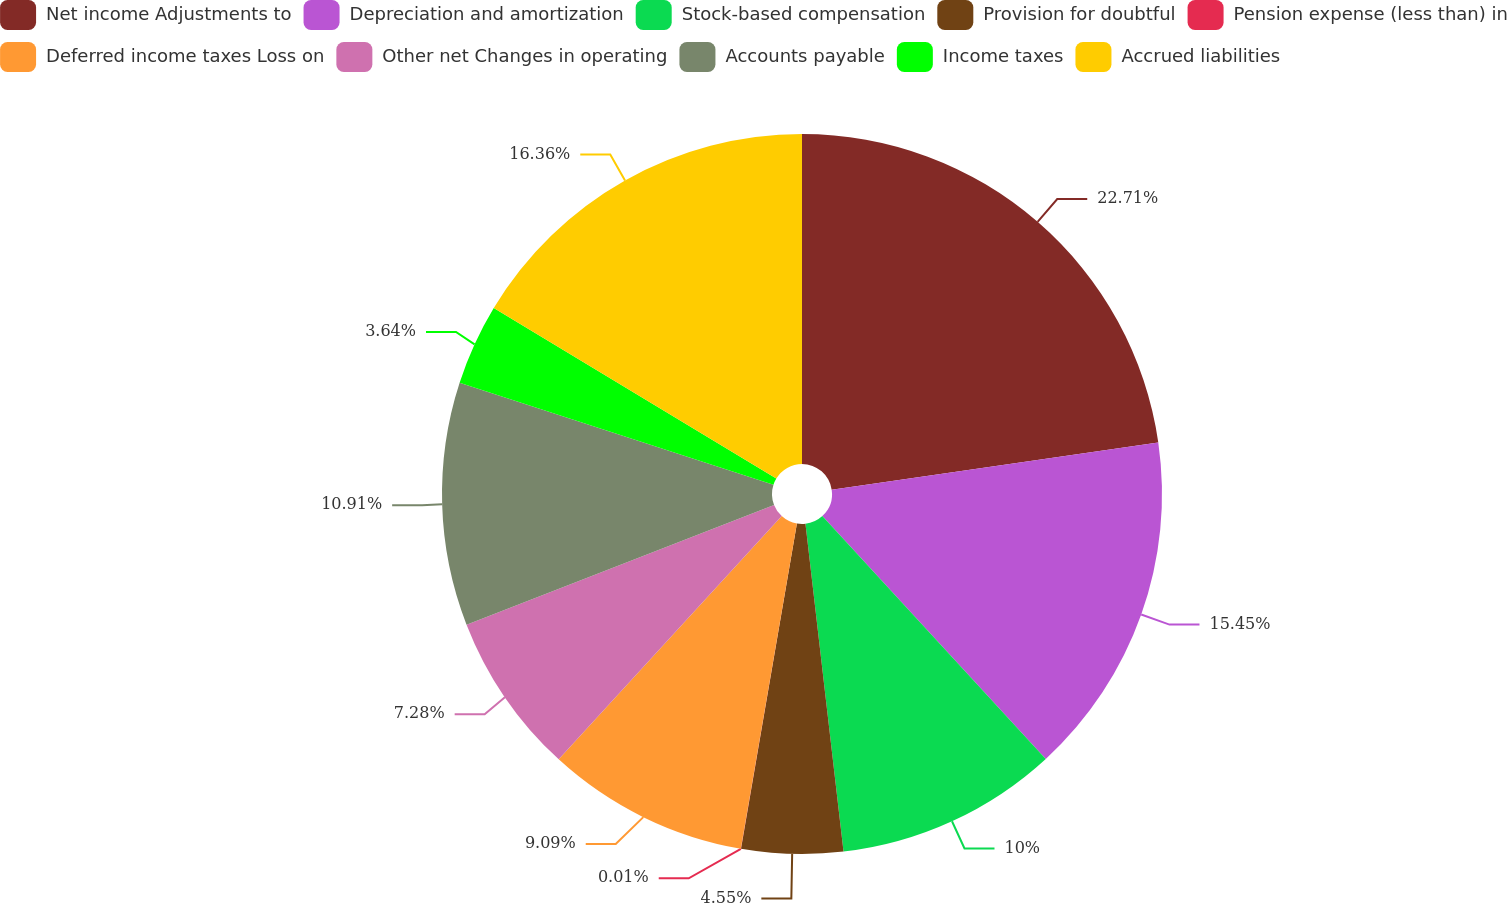Convert chart. <chart><loc_0><loc_0><loc_500><loc_500><pie_chart><fcel>Net income Adjustments to<fcel>Depreciation and amortization<fcel>Stock-based compensation<fcel>Provision for doubtful<fcel>Pension expense (less than) in<fcel>Deferred income taxes Loss on<fcel>Other net Changes in operating<fcel>Accounts payable<fcel>Income taxes<fcel>Accrued liabilities<nl><fcel>22.71%<fcel>15.45%<fcel>10.0%<fcel>4.55%<fcel>0.01%<fcel>9.09%<fcel>7.28%<fcel>10.91%<fcel>3.64%<fcel>16.36%<nl></chart> 